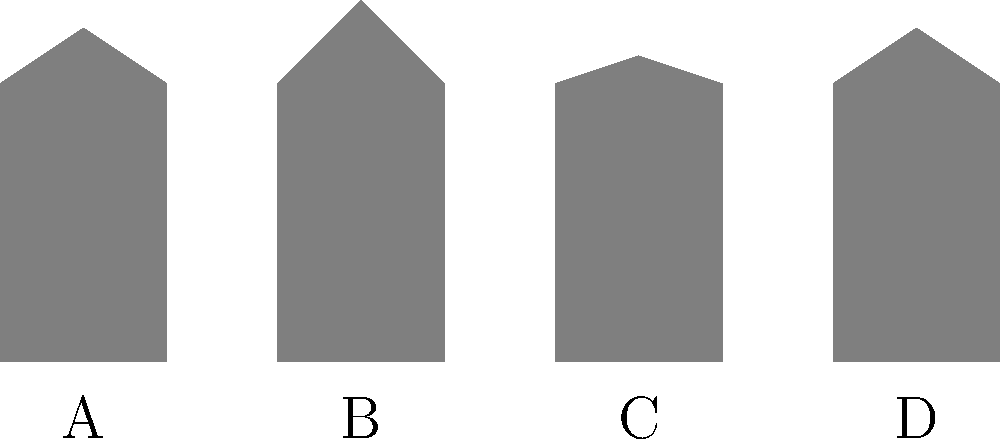Identify the silhouette that represents Freddie Prinze Jr.'s character from the movie "She's All That" (1999). To identify the correct silhouette, let's consider Freddie Prinze Jr.'s character in "She's All That":

1. In the movie, Freddie plays Zack Siler, a popular high school jock.
2. Zack's signature look includes spiky hair, which was trendy in the late 90s.
3. The character often wore casual clothing, giving him a relaxed silhouette.
4. Looking at the silhouettes:
   A: Has a flat top, unlike Zack's spiky hair.
   B: Shows spiky hair and a casual posture, matching Zack's appearance.
   C: Has a rounder head shape, not consistent with Zack's look.
   D: Shows longer hair, which doesn't match Zack's short, spiky style.

5. Based on these observations, silhouette B best represents Freddie Prinze Jr.'s character from "She's All That."
Answer: B 